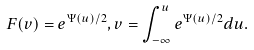<formula> <loc_0><loc_0><loc_500><loc_500>F ( v ) = e ^ { \Psi ( u ) / 2 } , v = \int _ { - \infty } ^ { u } e ^ { \Psi ( u ) / 2 } d u .</formula> 